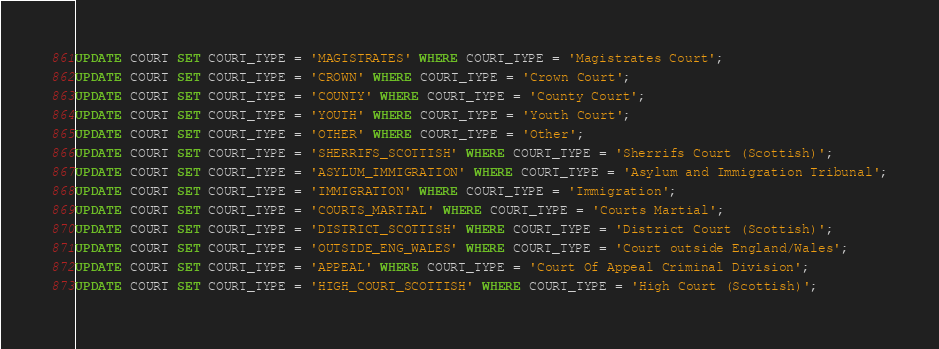<code> <loc_0><loc_0><loc_500><loc_500><_SQL_>UPDATE COURT SET COURT_TYPE = 'MAGISTRATES' WHERE COURT_TYPE = 'Magistrates Court';
UPDATE COURT SET COURT_TYPE = 'CROWN' WHERE COURT_TYPE = 'Crown Court';
UPDATE COURT SET COURT_TYPE = 'COUNTY' WHERE COURT_TYPE = 'County Court';
UPDATE COURT SET COURT_TYPE = 'YOUTH' WHERE COURT_TYPE = 'Youth Court';
UPDATE COURT SET COURT_TYPE = 'OTHER' WHERE COURT_TYPE = 'Other';
UPDATE COURT SET COURT_TYPE = 'SHERRIFS_SCOTTISH' WHERE COURT_TYPE = 'Sherrifs Court (Scottish)';
UPDATE COURT SET COURT_TYPE = 'ASYLUM_IMMIGRATION' WHERE COURT_TYPE = 'Asylum and Immigration Tribunal';
UPDATE COURT SET COURT_TYPE = 'IMMIGRATION' WHERE COURT_TYPE = 'Immigration';
UPDATE COURT SET COURT_TYPE = 'COURTS_MARTIAL' WHERE COURT_TYPE = 'Courts Martial';
UPDATE COURT SET COURT_TYPE = 'DISTRICT_SCOTTISH' WHERE COURT_TYPE = 'District Court (Scottish)';
UPDATE COURT SET COURT_TYPE = 'OUTSIDE_ENG_WALES' WHERE COURT_TYPE = 'Court outside England/Wales';
UPDATE COURT SET COURT_TYPE = 'APPEAL' WHERE COURT_TYPE = 'Court Of Appeal Criminal Division';
UPDATE COURT SET COURT_TYPE = 'HIGH_COURT_SCOTTISH' WHERE COURT_TYPE = 'High Court (Scottish)';



</code> 